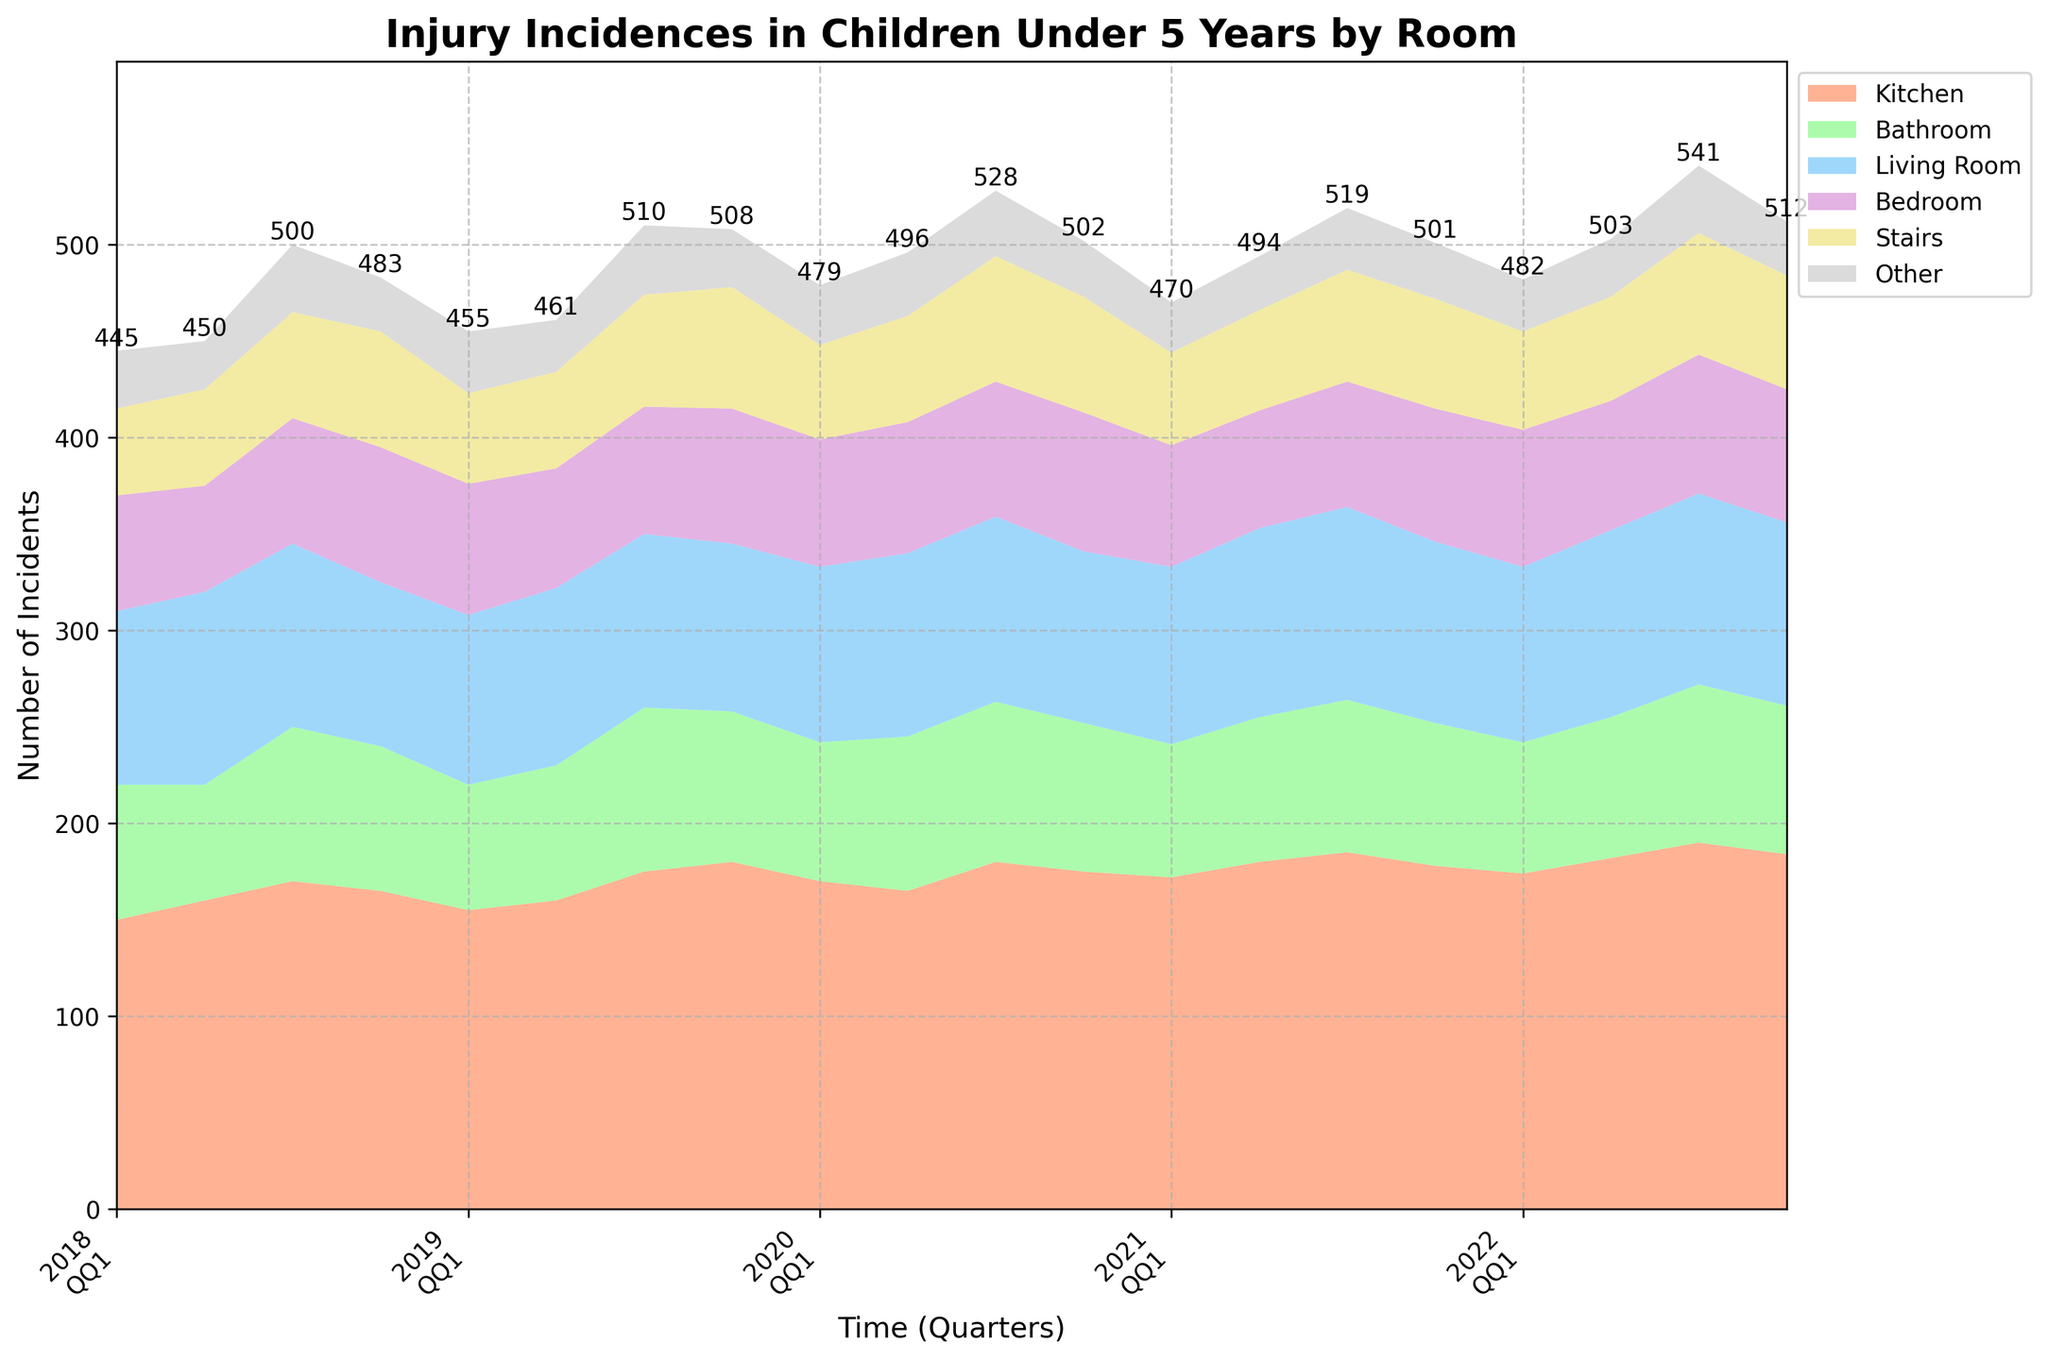What is the title of the figure? The title is usually located at the top of the figure and provides a summary of what the chart represents. Here, it reads "Injury Incidences in Children Under 5 Years by Room".
Answer: Injury Incidences in Children Under 5 Years by Room How many rooms are tracked for injury incidences? The legend or labels in the figure indicate the categories. Here, the figure tracks incidences for six rooms: Kitchen, Bathroom, Living Room, Bedroom, Stairs, and Other.
Answer: Six rooms Which room had the highest number of injury incidences in Q3 of 2022? Locate Q3 of 2022 on the x-axis and follow the corresponding segment upwards to see which area has the largest contribution at that quarter. According to the color-coded areas, the Kitchen has the highest number.
Answer: Kitchen What is the trend in injury incidences in the Kitchen from 2018 to 2022? Examine the section of the area chart related to the Kitchen area across all quarters from 2018 to 2022. The Kitchen's section consistently grows year over year, indicating an increasing trend in injury incidences.
Answer: Increasing Comparing Q1 and Q3 of 2021, which room showed the greatest increase in injury incidences? Find Q1 2021 and Q3 2021 on the x-axis, then compare the size of the areas for each room. The Kitchen shows the greatest increase between these quarters.
Answer: Kitchen What is the total number of injury incidences in Q4 of 2020? Identify Q4 2020 on the x-axis and locate the top line that represents the total number of incidences by adding up the top values of each room's section. The sum is 175 (Kitchen) + 77 (Bathroom) + 89 (Living Room) + 72 (Bedroom) + 60 (Stairs) + 29 (Other).
Answer: 502 Which room has the lowest overall contribution to injury incidences throughout the entire period? Observe the size and contribution of each area throughout the entire period. The "Other" room consistently has the smallest area, indicating the lowest overall contribution.
Answer: Other During which quarter do injury incidences peak overall? Track the top edge of the chart to find the highest point. The figure peaks during Q3 of 2022.
Answer: Q3 2022 What can you infer about the overall trend in injury incidences in the Living Room from 2018 to 2022? Examine the Living Room section for each quarter from 2018 to 2022. The trend shows fluctuations but a reasonable increase in the incidence numbers towards the end of the period.
Answer: Increasing How did injury incidences on Stairs change from Q1 2018 to Q4 2022? Start from Q1 2018 and follow the area corresponding to the Stairs section to Q4 2022. While there are fluctuations, the overall trend shows an increase by the end of the period.
Answer: Increasing 